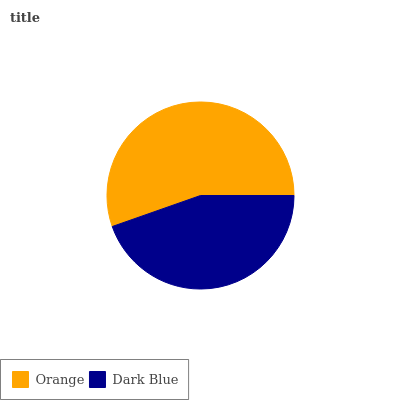Is Dark Blue the minimum?
Answer yes or no. Yes. Is Orange the maximum?
Answer yes or no. Yes. Is Dark Blue the maximum?
Answer yes or no. No. Is Orange greater than Dark Blue?
Answer yes or no. Yes. Is Dark Blue less than Orange?
Answer yes or no. Yes. Is Dark Blue greater than Orange?
Answer yes or no. No. Is Orange less than Dark Blue?
Answer yes or no. No. Is Orange the high median?
Answer yes or no. Yes. Is Dark Blue the low median?
Answer yes or no. Yes. Is Dark Blue the high median?
Answer yes or no. No. Is Orange the low median?
Answer yes or no. No. 